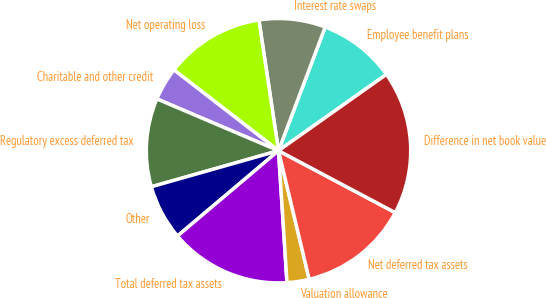Convert chart. <chart><loc_0><loc_0><loc_500><loc_500><pie_chart><fcel>Employee benefit plans<fcel>Interest rate swaps<fcel>Net operating loss<fcel>Charitable and other credit<fcel>Regulatory excess deferred tax<fcel>Other<fcel>Total deferred tax assets<fcel>Valuation allowance<fcel>Net deferred tax assets<fcel>Difference in net book value<nl><fcel>9.46%<fcel>8.11%<fcel>12.16%<fcel>4.06%<fcel>10.81%<fcel>6.76%<fcel>14.86%<fcel>2.71%<fcel>13.51%<fcel>17.56%<nl></chart> 